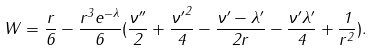<formula> <loc_0><loc_0><loc_500><loc_500>W = \frac { r } { 6 } - \frac { r ^ { 3 } e ^ { - \lambda } } { 6 } ( \frac { { \nu } ^ { \prime \prime } } { 2 } + \frac { { \nu ^ { \prime } } ^ { 2 } } { 4 } - \frac { { { \nu } ^ { \prime } } - { { \lambda } ^ { \prime } } } { 2 r } - \frac { { \nu } ^ { \prime } { \lambda } ^ { \prime } } { 4 } + \frac { 1 } { r ^ { 2 } } ) .</formula> 